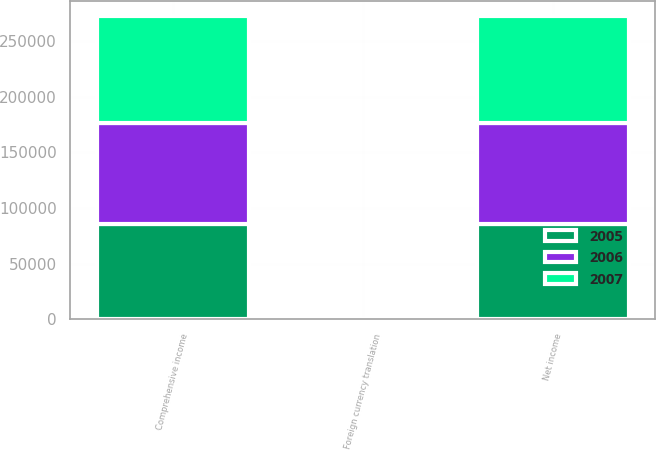Convert chart. <chart><loc_0><loc_0><loc_500><loc_500><stacked_bar_chart><ecel><fcel>Net income<fcel>Foreign currency translation<fcel>Comprehensive income<nl><fcel>2007<fcel>96241<fcel>22<fcel>96263<nl><fcel>2006<fcel>91008<fcel>11<fcel>90997<nl><fcel>2005<fcel>85669<fcel>11<fcel>85658<nl></chart> 